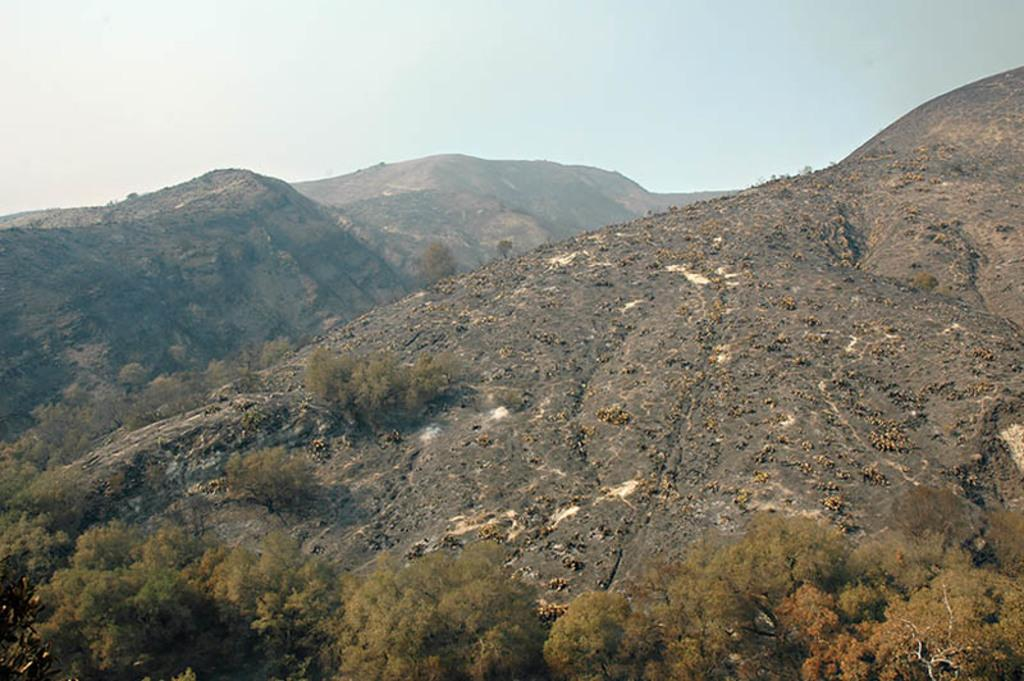What type of vegetation can be seen in the image? There are trees in the image. What color are the trees? The trees are green. What can be seen in the distance behind the trees? There are mountains in the background of the image. What colors are visible in the sky? The sky is blue and white. What type of game is being played on top of the trees in the image? There is no game being played in the image; it features trees, mountains, and a blue and white sky. 